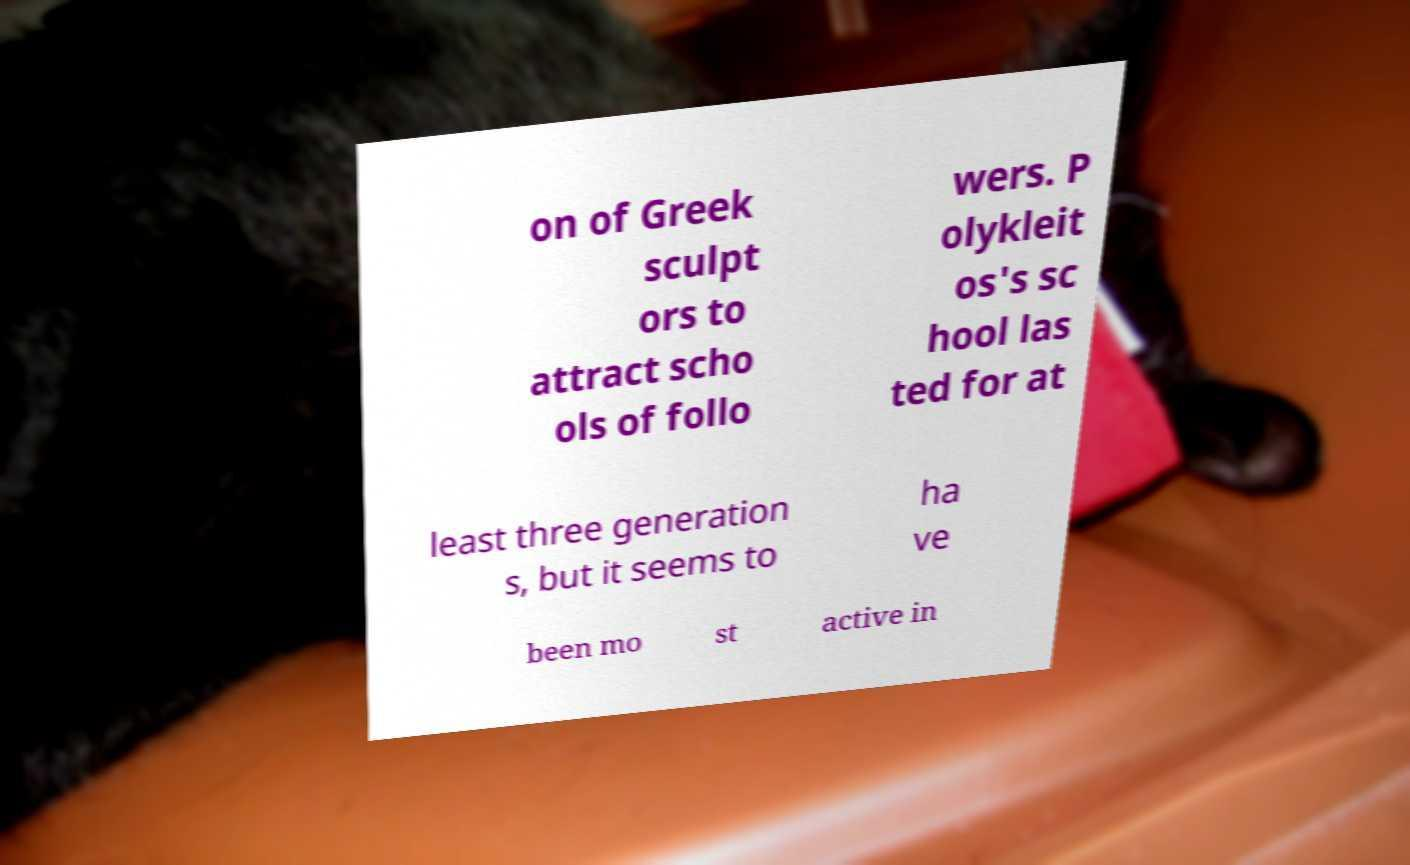Can you accurately transcribe the text from the provided image for me? on of Greek sculpt ors to attract scho ols of follo wers. P olykleit os's sc hool las ted for at least three generation s, but it seems to ha ve been mo st active in 